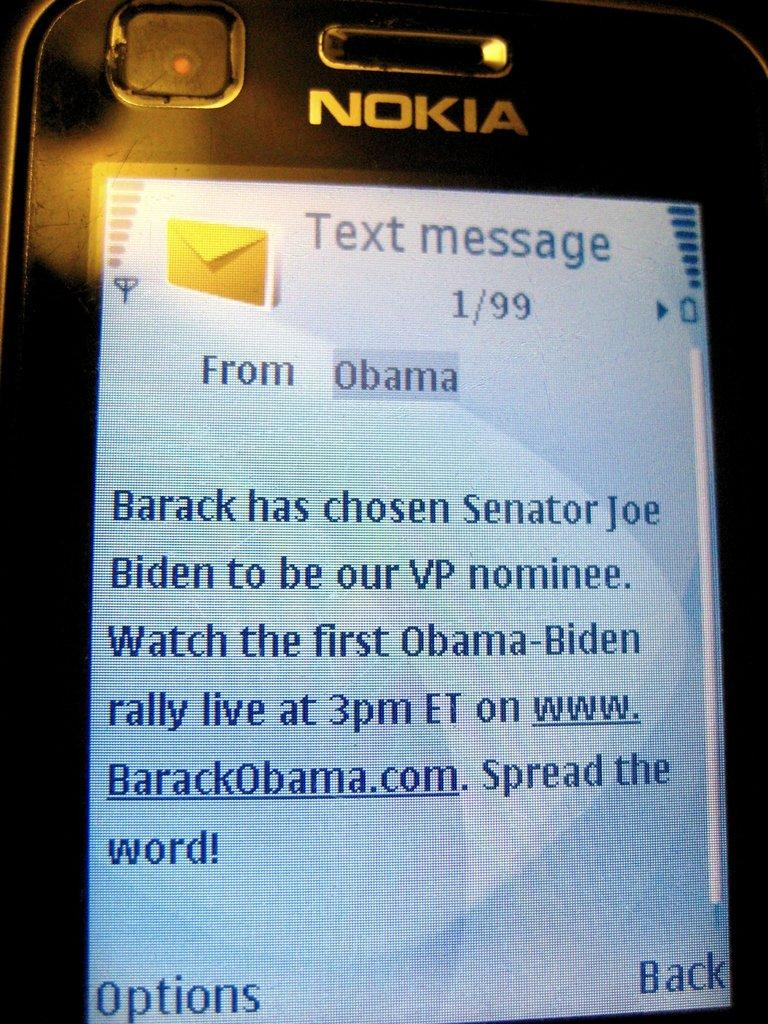<image>
Describe the image concisely. The nokia phone shows a text message from Obama. 